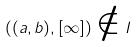Convert formula to latex. <formula><loc_0><loc_0><loc_500><loc_500>( ( a , b ) , [ \infty ] ) \notin I</formula> 